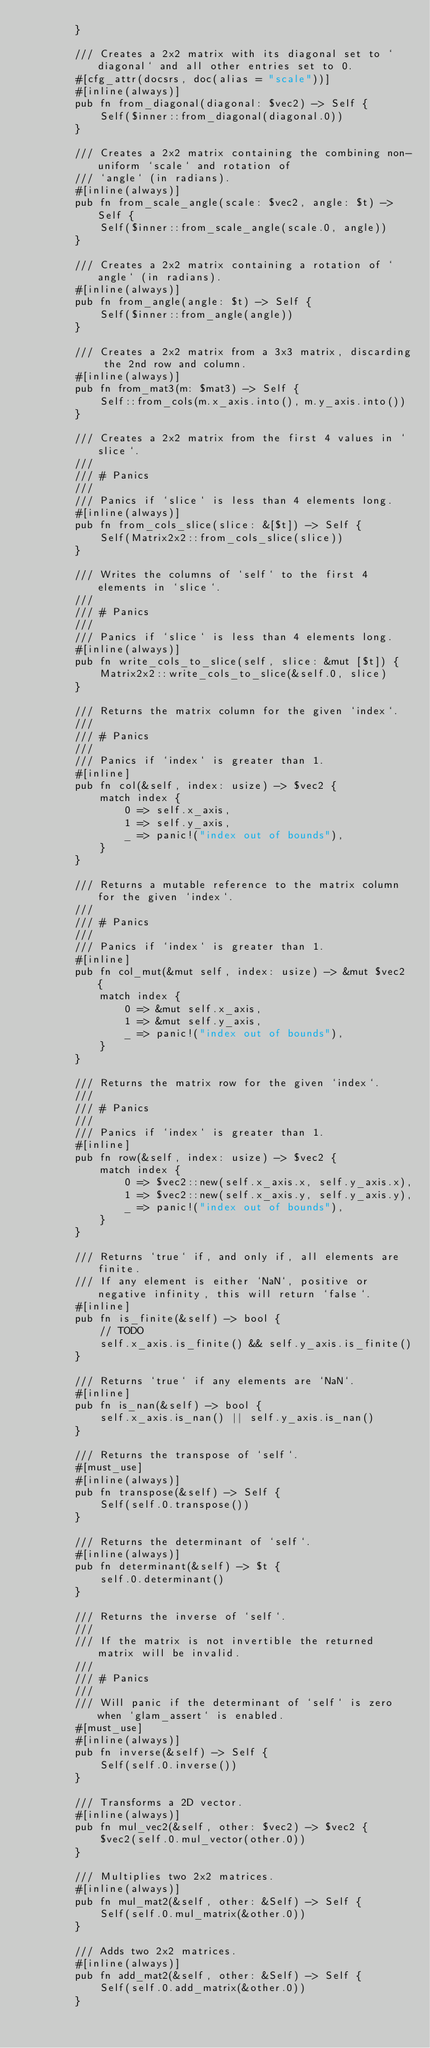Convert code to text. <code><loc_0><loc_0><loc_500><loc_500><_Rust_>        }

        /// Creates a 2x2 matrix with its diagonal set to `diagonal` and all other entries set to 0.
        #[cfg_attr(docsrs, doc(alias = "scale"))]
        #[inline(always)]
        pub fn from_diagonal(diagonal: $vec2) -> Self {
            Self($inner::from_diagonal(diagonal.0))
        }

        /// Creates a 2x2 matrix containing the combining non-uniform `scale` and rotation of
        /// `angle` (in radians).
        #[inline(always)]
        pub fn from_scale_angle(scale: $vec2, angle: $t) -> Self {
            Self($inner::from_scale_angle(scale.0, angle))
        }

        /// Creates a 2x2 matrix containing a rotation of `angle` (in radians).
        #[inline(always)]
        pub fn from_angle(angle: $t) -> Self {
            Self($inner::from_angle(angle))
        }

        /// Creates a 2x2 matrix from a 3x3 matrix, discarding the 2nd row and column.
        #[inline(always)]
        pub fn from_mat3(m: $mat3) -> Self {
            Self::from_cols(m.x_axis.into(), m.y_axis.into())
        }

        /// Creates a 2x2 matrix from the first 4 values in `slice`.
        ///
        /// # Panics
        ///
        /// Panics if `slice` is less than 4 elements long.
        #[inline(always)]
        pub fn from_cols_slice(slice: &[$t]) -> Self {
            Self(Matrix2x2::from_cols_slice(slice))
        }

        /// Writes the columns of `self` to the first 4 elements in `slice`.
        ///
        /// # Panics
        ///
        /// Panics if `slice` is less than 4 elements long.
        #[inline(always)]
        pub fn write_cols_to_slice(self, slice: &mut [$t]) {
            Matrix2x2::write_cols_to_slice(&self.0, slice)
        }

        /// Returns the matrix column for the given `index`.
        ///
        /// # Panics
        ///
        /// Panics if `index` is greater than 1.
        #[inline]
        pub fn col(&self, index: usize) -> $vec2 {
            match index {
                0 => self.x_axis,
                1 => self.y_axis,
                _ => panic!("index out of bounds"),
            }
        }

        /// Returns a mutable reference to the matrix column for the given `index`.
        ///
        /// # Panics
        ///
        /// Panics if `index` is greater than 1.
        #[inline]
        pub fn col_mut(&mut self, index: usize) -> &mut $vec2 {
            match index {
                0 => &mut self.x_axis,
                1 => &mut self.y_axis,
                _ => panic!("index out of bounds"),
            }
        }

        /// Returns the matrix row for the given `index`.
        ///
        /// # Panics
        ///
        /// Panics if `index` is greater than 1.
        #[inline]
        pub fn row(&self, index: usize) -> $vec2 {
            match index {
                0 => $vec2::new(self.x_axis.x, self.y_axis.x),
                1 => $vec2::new(self.x_axis.y, self.y_axis.y),
                _ => panic!("index out of bounds"),
            }
        }

        /// Returns `true` if, and only if, all elements are finite.
        /// If any element is either `NaN`, positive or negative infinity, this will return `false`.
        #[inline]
        pub fn is_finite(&self) -> bool {
            // TODO
            self.x_axis.is_finite() && self.y_axis.is_finite()
        }

        /// Returns `true` if any elements are `NaN`.
        #[inline]
        pub fn is_nan(&self) -> bool {
            self.x_axis.is_nan() || self.y_axis.is_nan()
        }

        /// Returns the transpose of `self`.
        #[must_use]
        #[inline(always)]
        pub fn transpose(&self) -> Self {
            Self(self.0.transpose())
        }

        /// Returns the determinant of `self`.
        #[inline(always)]
        pub fn determinant(&self) -> $t {
            self.0.determinant()
        }

        /// Returns the inverse of `self`.
        ///
        /// If the matrix is not invertible the returned matrix will be invalid.
        ///
        /// # Panics
        ///
        /// Will panic if the determinant of `self` is zero when `glam_assert` is enabled.
        #[must_use]
        #[inline(always)]
        pub fn inverse(&self) -> Self {
            Self(self.0.inverse())
        }

        /// Transforms a 2D vector.
        #[inline(always)]
        pub fn mul_vec2(&self, other: $vec2) -> $vec2 {
            $vec2(self.0.mul_vector(other.0))
        }

        /// Multiplies two 2x2 matrices.
        #[inline(always)]
        pub fn mul_mat2(&self, other: &Self) -> Self {
            Self(self.0.mul_matrix(&other.0))
        }

        /// Adds two 2x2 matrices.
        #[inline(always)]
        pub fn add_mat2(&self, other: &Self) -> Self {
            Self(self.0.add_matrix(&other.0))
        }
</code> 